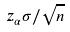<formula> <loc_0><loc_0><loc_500><loc_500>z _ { \alpha } \sigma / \sqrt { n }</formula> 